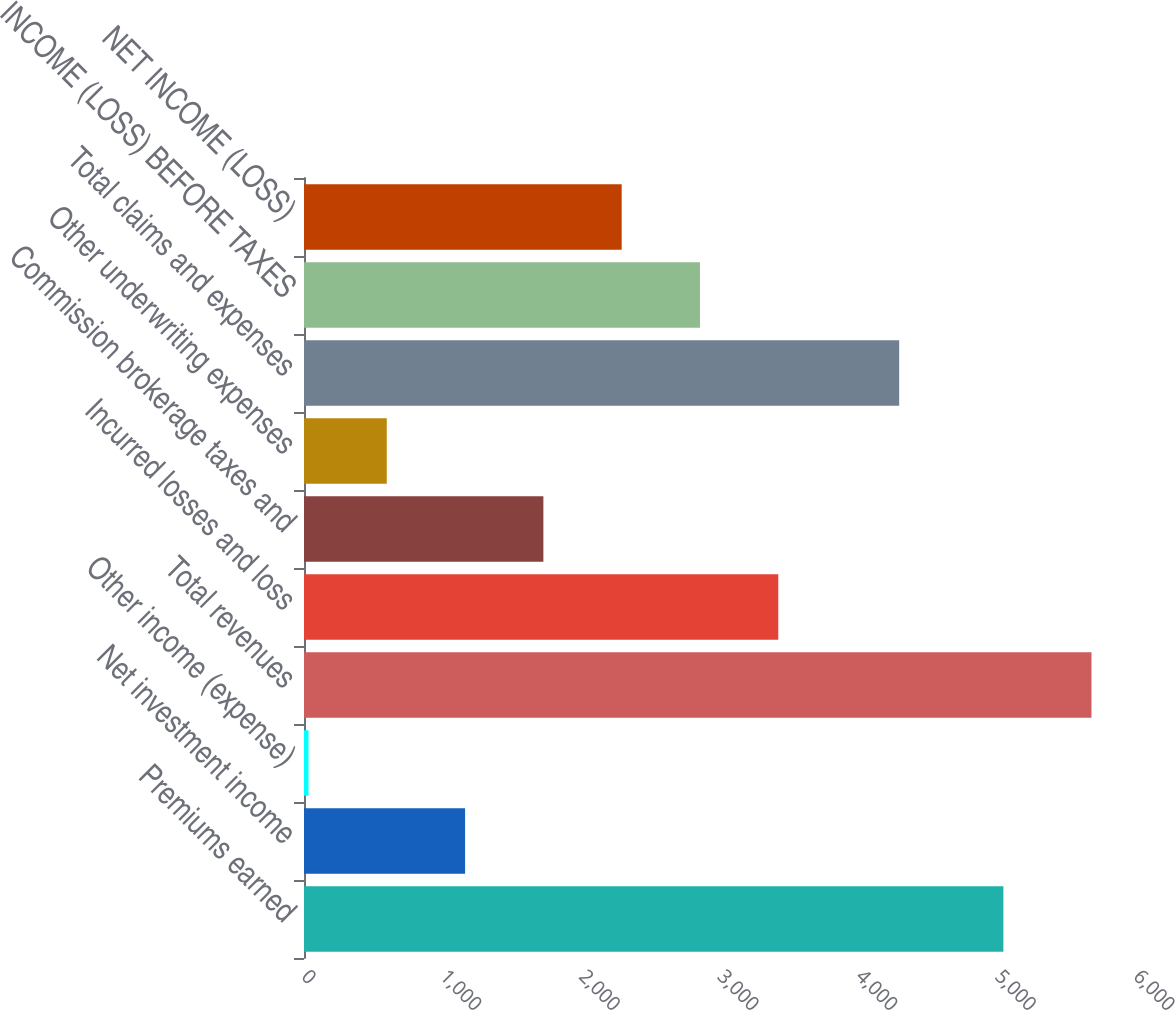Convert chart. <chart><loc_0><loc_0><loc_500><loc_500><bar_chart><fcel>Premiums earned<fcel>Net investment income<fcel>Other income (expense)<fcel>Total revenues<fcel>Incurred losses and loss<fcel>Commission brokerage taxes and<fcel>Other underwriting expenses<fcel>Total claims and expenses<fcel>INCOME (LOSS) BEFORE TAXES<fcel>NET INCOME (LOSS)<nl><fcel>5043.7<fcel>1161.62<fcel>32.3<fcel>5678.9<fcel>3420.26<fcel>1726.28<fcel>596.96<fcel>4292.1<fcel>2855.6<fcel>2290.94<nl></chart> 